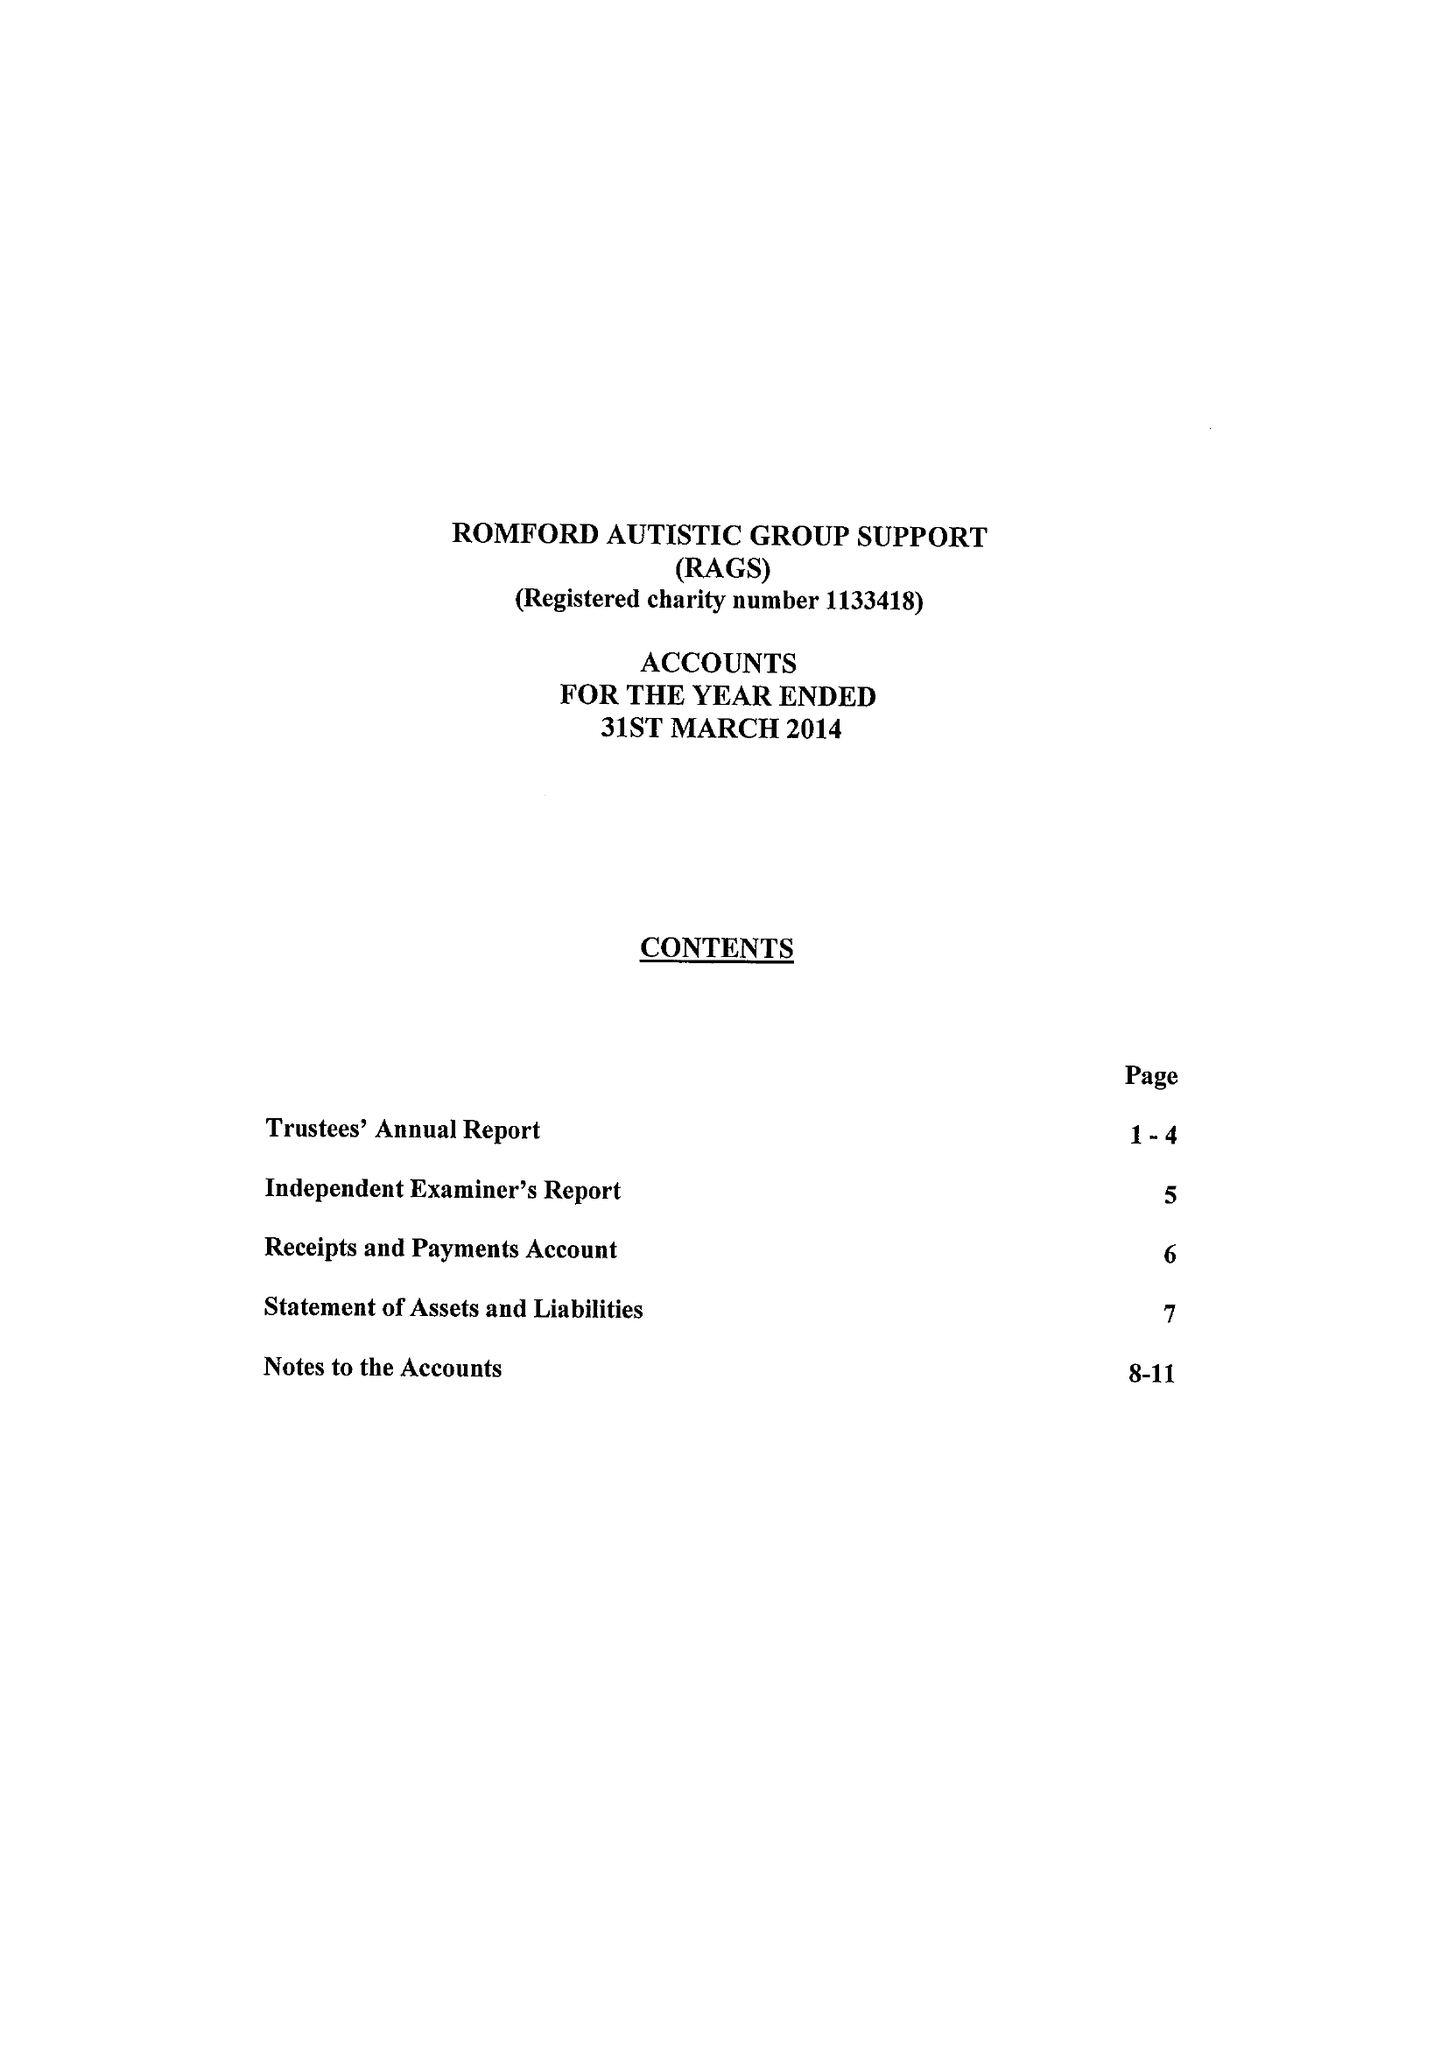What is the value for the address__street_line?
Answer the question using a single word or phrase. 90 TAUNTON ROAD 